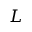<formula> <loc_0><loc_0><loc_500><loc_500>L</formula> 